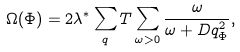<formula> <loc_0><loc_0><loc_500><loc_500>\Omega ( \Phi ) = 2 \lambda ^ { * } \sum _ { q } T \sum _ { \omega > 0 } \frac { \omega } { \omega + D q _ { \Phi } ^ { 2 } } ,</formula> 